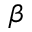Convert formula to latex. <formula><loc_0><loc_0><loc_500><loc_500>\beta</formula> 